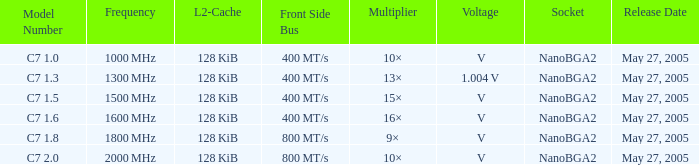What is the periodicity for model number c7 1000 MHz. 